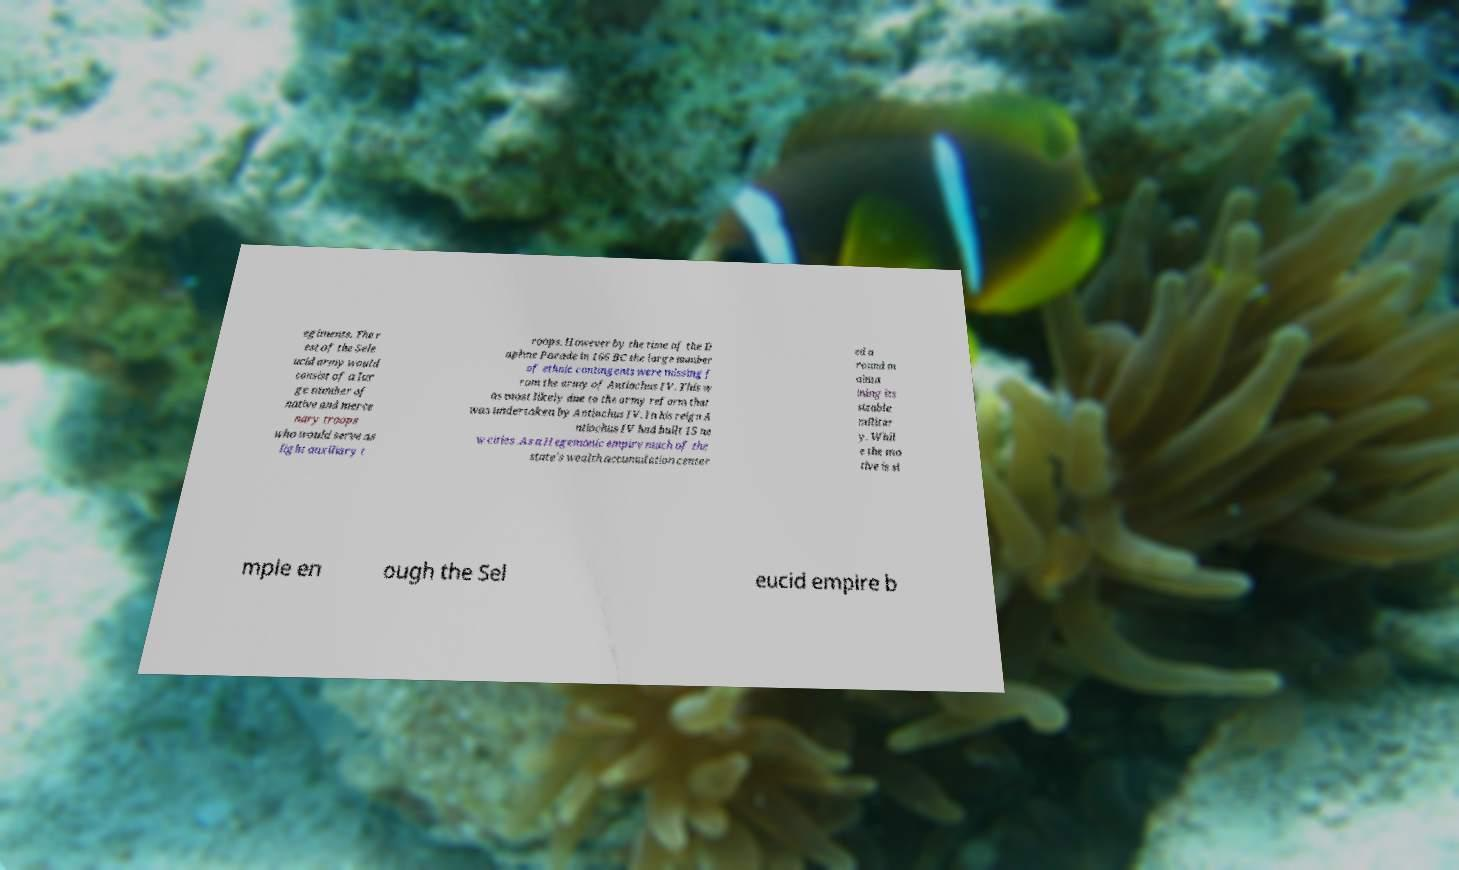For documentation purposes, I need the text within this image transcribed. Could you provide that? egiments. The r est of the Sele ucid army would consist of a lar ge number of native and merce nary troops who would serve as light auxiliary t roops. However by the time of the D aphne Parade in 166 BC the large number of ethnic contingents were missing f rom the army of Antiochus IV. This w as most likely due to the army reform that was undertaken by Antiochus IV. In his reign A ntiochus IV had built 15 ne w cities .As a Hegemonic empire much of the state's wealth accumulation center ed a round m ainta ining its sizable militar y. Whil e the mo tive is si mple en ough the Sel eucid empire b 